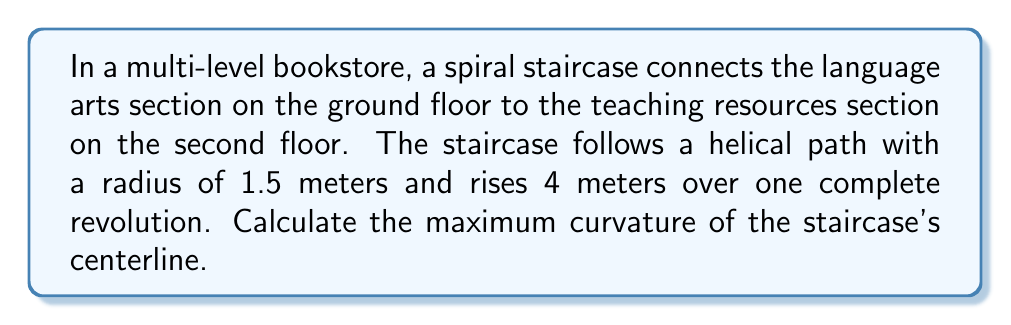Could you help me with this problem? To solve this problem, we'll follow these steps:

1) The parametric equations for a helix are:
   $$x = r\cos(t)$$
   $$y = r\sin(t)$$
   $$z = ct$$
   where $r$ is the radius and $c$ is the vertical distance traveled in one revolution.

2) In this case, $r = 1.5$ m and $c = 4$ m. Let's parameterize over $2\pi$:
   $$x = 1.5\cos(t)$$
   $$y = 1.5\sin(t)$$
   $$z = \frac{2}{\pi}t$$

3) The curvature $\kappa$ of a space curve is given by:
   $$\kappa = \frac{|\mathbf{r}'(t) \times \mathbf{r}''(t)|}{|\mathbf{r}'(t)|^3}$$

4) Let's calculate $\mathbf{r}'(t)$ and $\mathbf{r}''(t)$:
   $$\mathbf{r}'(t) = (-1.5\sin(t), 1.5\cos(t), \frac{2}{\pi})$$
   $$\mathbf{r}''(t) = (-1.5\cos(t), -1.5\sin(t), 0)$$

5) Now, let's calculate $|\mathbf{r}'(t) \times \mathbf{r}''(t)|$:
   $$|\mathbf{r}'(t) \times \mathbf{r}''(t)| = \sqrt{(1.5 \cdot \frac{2}{\pi})^2 + (1.5 \cdot \frac{2}{\pi})^2 + (1.5^2 + 1.5^2)^2} = \sqrt{\frac{9}{\pi^2} + 9} = 3\sqrt{1 + \frac{1}{\pi^2}}$$

6) Next, calculate $|\mathbf{r}'(t)|^3$:
   $$|\mathbf{r}'(t)|^3 = (1.5^2 + 1.5^2 + (\frac{2}{\pi})^2)^{3/2} = (\frac{9\pi^2 + 4}{4\pi^2})^{3/2}$$

7) The curvature is therefore:
   $$\kappa = \frac{3\sqrt{1 + \frac{1}{\pi^2}}}{(\frac{9\pi^2 + 4}{4\pi^2})^{3/2}}$$

8) This curvature is constant for all points on the helix, so it's also the maximum curvature.
Answer: $\frac{3\sqrt{1 + \frac{1}{\pi^2}}}{(\frac{9\pi^2 + 4}{4\pi^2})^{3/2}}$ m$^{-1}$ 